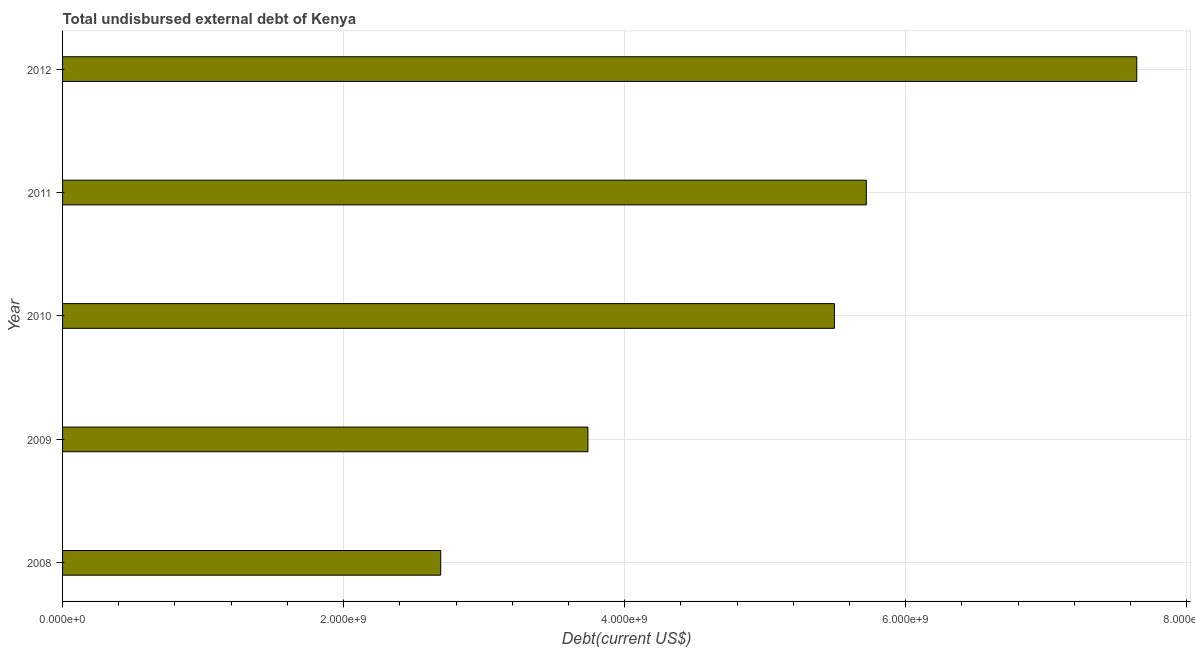Does the graph contain grids?
Give a very brief answer. Yes. What is the title of the graph?
Your answer should be very brief. Total undisbursed external debt of Kenya. What is the label or title of the X-axis?
Keep it short and to the point. Debt(current US$). What is the total debt in 2010?
Make the answer very short. 5.49e+09. Across all years, what is the maximum total debt?
Provide a succinct answer. 7.64e+09. Across all years, what is the minimum total debt?
Offer a terse response. 2.69e+09. In which year was the total debt maximum?
Offer a very short reply. 2012. In which year was the total debt minimum?
Your answer should be very brief. 2008. What is the sum of the total debt?
Keep it short and to the point. 2.53e+1. What is the difference between the total debt in 2011 and 2012?
Offer a very short reply. -1.92e+09. What is the average total debt per year?
Offer a terse response. 5.06e+09. What is the median total debt?
Keep it short and to the point. 5.49e+09. In how many years, is the total debt greater than 4800000000 US$?
Your response must be concise. 3. What is the ratio of the total debt in 2009 to that in 2012?
Your response must be concise. 0.49. Is the total debt in 2009 less than that in 2011?
Make the answer very short. Yes. What is the difference between the highest and the second highest total debt?
Provide a succinct answer. 1.92e+09. Is the sum of the total debt in 2011 and 2012 greater than the maximum total debt across all years?
Your answer should be very brief. Yes. What is the difference between the highest and the lowest total debt?
Provide a succinct answer. 4.95e+09. In how many years, is the total debt greater than the average total debt taken over all years?
Offer a very short reply. 3. How many bars are there?
Make the answer very short. 5. Are all the bars in the graph horizontal?
Your answer should be compact. Yes. How many years are there in the graph?
Ensure brevity in your answer.  5. What is the Debt(current US$) of 2008?
Provide a succinct answer. 2.69e+09. What is the Debt(current US$) in 2009?
Give a very brief answer. 3.74e+09. What is the Debt(current US$) in 2010?
Provide a succinct answer. 5.49e+09. What is the Debt(current US$) in 2011?
Your answer should be compact. 5.72e+09. What is the Debt(current US$) in 2012?
Offer a terse response. 7.64e+09. What is the difference between the Debt(current US$) in 2008 and 2009?
Your answer should be compact. -1.05e+09. What is the difference between the Debt(current US$) in 2008 and 2010?
Ensure brevity in your answer.  -2.80e+09. What is the difference between the Debt(current US$) in 2008 and 2011?
Provide a short and direct response. -3.03e+09. What is the difference between the Debt(current US$) in 2008 and 2012?
Offer a very short reply. -4.95e+09. What is the difference between the Debt(current US$) in 2009 and 2010?
Provide a short and direct response. -1.75e+09. What is the difference between the Debt(current US$) in 2009 and 2011?
Provide a short and direct response. -1.98e+09. What is the difference between the Debt(current US$) in 2009 and 2012?
Give a very brief answer. -3.91e+09. What is the difference between the Debt(current US$) in 2010 and 2011?
Provide a succinct answer. -2.27e+08. What is the difference between the Debt(current US$) in 2010 and 2012?
Provide a succinct answer. -2.15e+09. What is the difference between the Debt(current US$) in 2011 and 2012?
Offer a terse response. -1.92e+09. What is the ratio of the Debt(current US$) in 2008 to that in 2009?
Provide a succinct answer. 0.72. What is the ratio of the Debt(current US$) in 2008 to that in 2010?
Keep it short and to the point. 0.49. What is the ratio of the Debt(current US$) in 2008 to that in 2011?
Provide a short and direct response. 0.47. What is the ratio of the Debt(current US$) in 2008 to that in 2012?
Your answer should be compact. 0.35. What is the ratio of the Debt(current US$) in 2009 to that in 2010?
Your answer should be very brief. 0.68. What is the ratio of the Debt(current US$) in 2009 to that in 2011?
Offer a terse response. 0.65. What is the ratio of the Debt(current US$) in 2009 to that in 2012?
Keep it short and to the point. 0.49. What is the ratio of the Debt(current US$) in 2010 to that in 2012?
Offer a terse response. 0.72. What is the ratio of the Debt(current US$) in 2011 to that in 2012?
Your answer should be very brief. 0.75. 